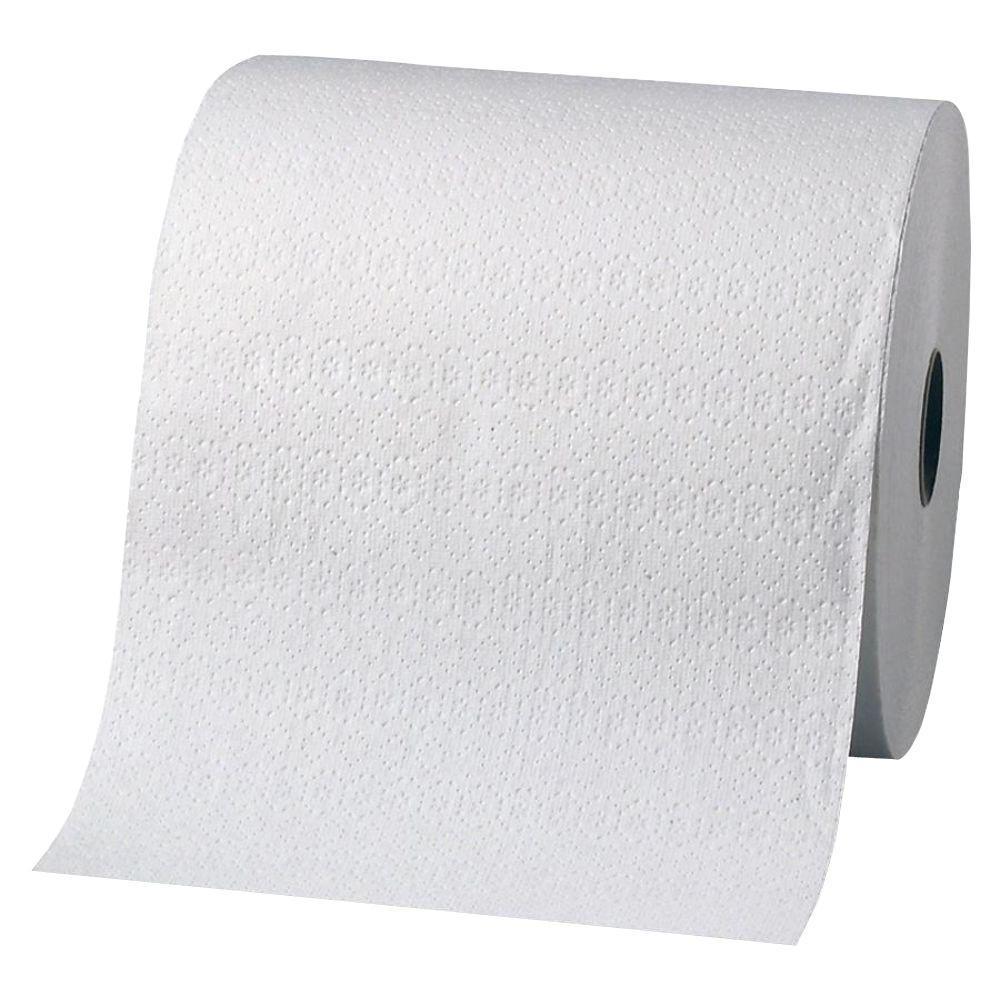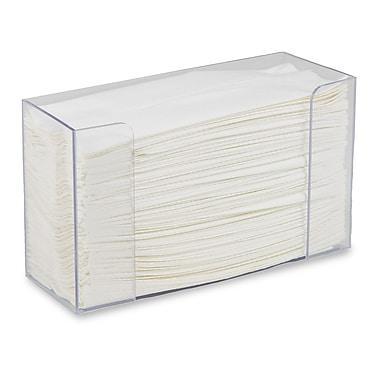The first image is the image on the left, the second image is the image on the right. Examine the images to the left and right. Is the description "At least 1 roll is standing vertically." accurate? Answer yes or no. No. 